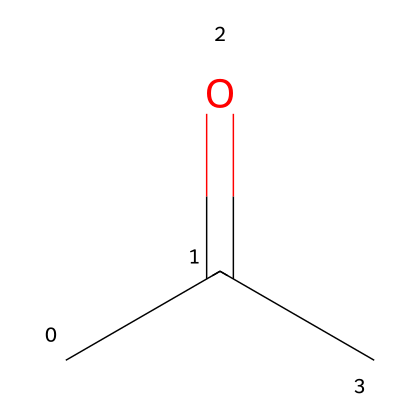How many carbon atoms are in acetone? The SMILES representation "CC(=O)C" shows three carbon atoms in total. The first "C" is one carbon, the second "C" connected to an oxygen is part of a carbonyl group (C=O), and the last "C" is a branching carbon, resulting in three carbon atoms overall.
Answer: three What type of functional group is present in acetone? The chemical structure of acetone includes a carbonyl group (C=O), which is characteristic of ketones. The presence of this specific arrangement indicates that acetone is a ketone by definition.
Answer: ketone How many hydrogen atoms are connected to acetone's carbon atoms? Upon examining the structure "CC(=O)C", we identify that there are six hydrogen atoms. The first carbon has three hydrogens, the connected carbon to oxygen has one hydrogen, and the last carbon again has three, totaling six hydrogens.
Answer: six What is the molecular formula of acetone? Based on the analysis of the structure, we see that it has three carbons, six hydrogens, and one oxygen. Thus, the molecular formula is determined to be C3H6O since it reflects all constituent atoms.
Answer: C3H6O How does acetone function as a solvent? Acetone has polar properties due to the presence of the carbonyl group, allowing it to dissolve both polar and nonpolar substances effectively. This makes it versatile as a solvent for various film makeup products, capable of breaking down oils and pigments.
Answer: versatile solvent What is the boiling point of acetone? Commonly accepted data states that acetone boils at approximately 56 degrees Celsius. This information reflects its physical properties as a solvent and its ability to evaporate quickly in applications like makeup removal.
Answer: 56 degrees Celsius 